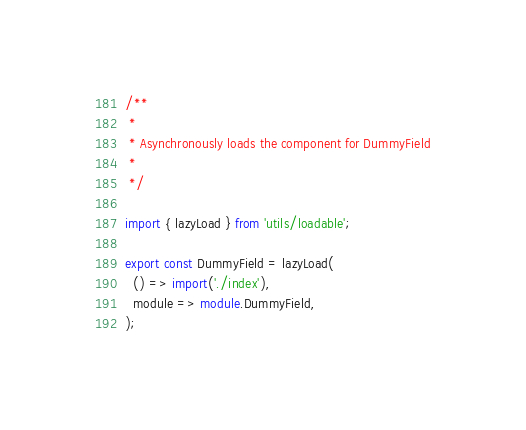Convert code to text. <code><loc_0><loc_0><loc_500><loc_500><_TypeScript_>/**
 *
 * Asynchronously loads the component for DummyField
 *
 */

import { lazyLoad } from 'utils/loadable';

export const DummyField = lazyLoad(
  () => import('./index'),
  module => module.DummyField,
);
</code> 